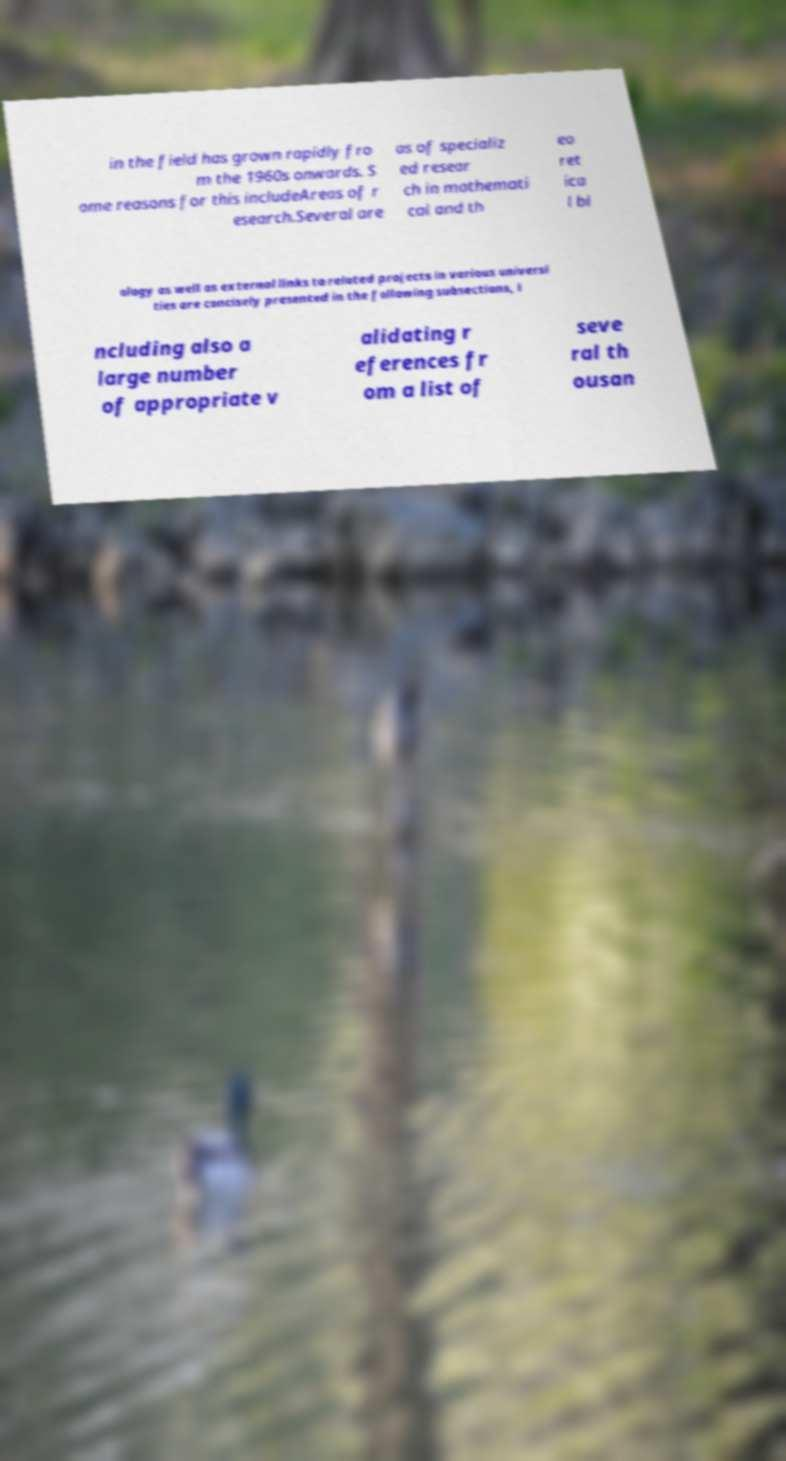Can you accurately transcribe the text from the provided image for me? in the field has grown rapidly fro m the 1960s onwards. S ome reasons for this includeAreas of r esearch.Several are as of specializ ed resear ch in mathemati cal and th eo ret ica l bi ology as well as external links to related projects in various universi ties are concisely presented in the following subsections, i ncluding also a large number of appropriate v alidating r eferences fr om a list of seve ral th ousan 